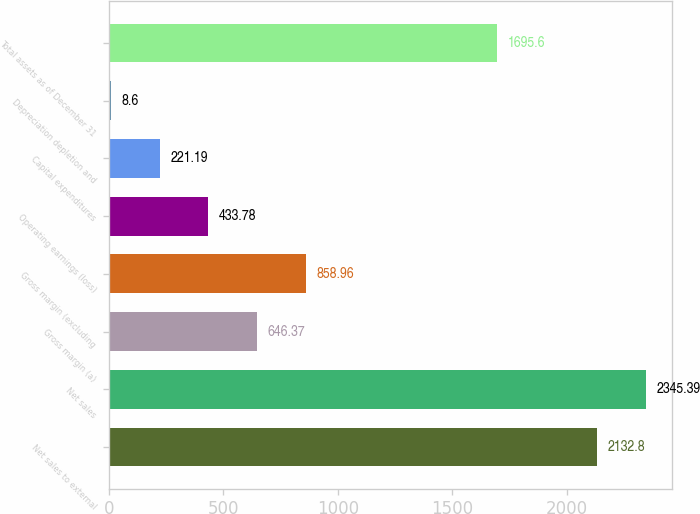<chart> <loc_0><loc_0><loc_500><loc_500><bar_chart><fcel>Net sales to external<fcel>Net sales<fcel>Gross margin (a)<fcel>Gross margin (excluding<fcel>Operating earnings (loss)<fcel>Capital expenditures<fcel>Depreciation depletion and<fcel>Total assets as of December 31<nl><fcel>2132.8<fcel>2345.39<fcel>646.37<fcel>858.96<fcel>433.78<fcel>221.19<fcel>8.6<fcel>1695.6<nl></chart> 